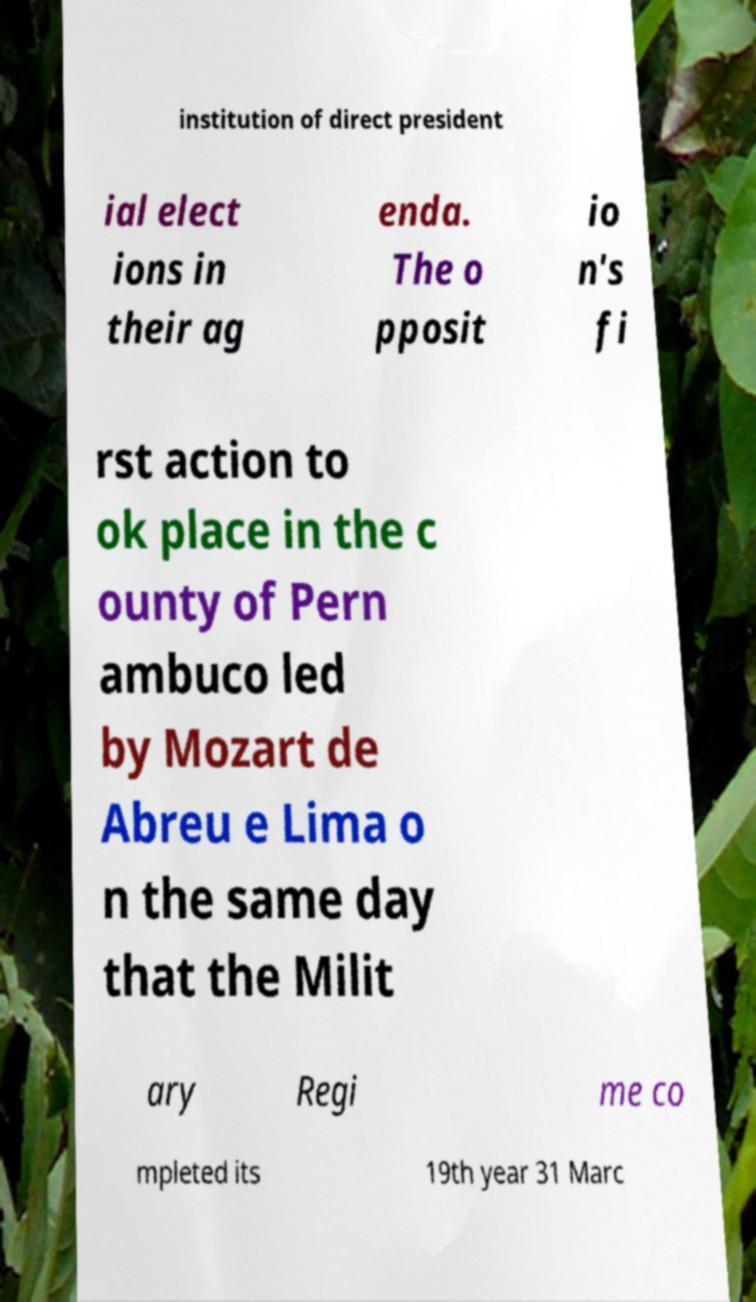Can you accurately transcribe the text from the provided image for me? institution of direct president ial elect ions in their ag enda. The o pposit io n's fi rst action to ok place in the c ounty of Pern ambuco led by Mozart de Abreu e Lima o n the same day that the Milit ary Regi me co mpleted its 19th year 31 Marc 